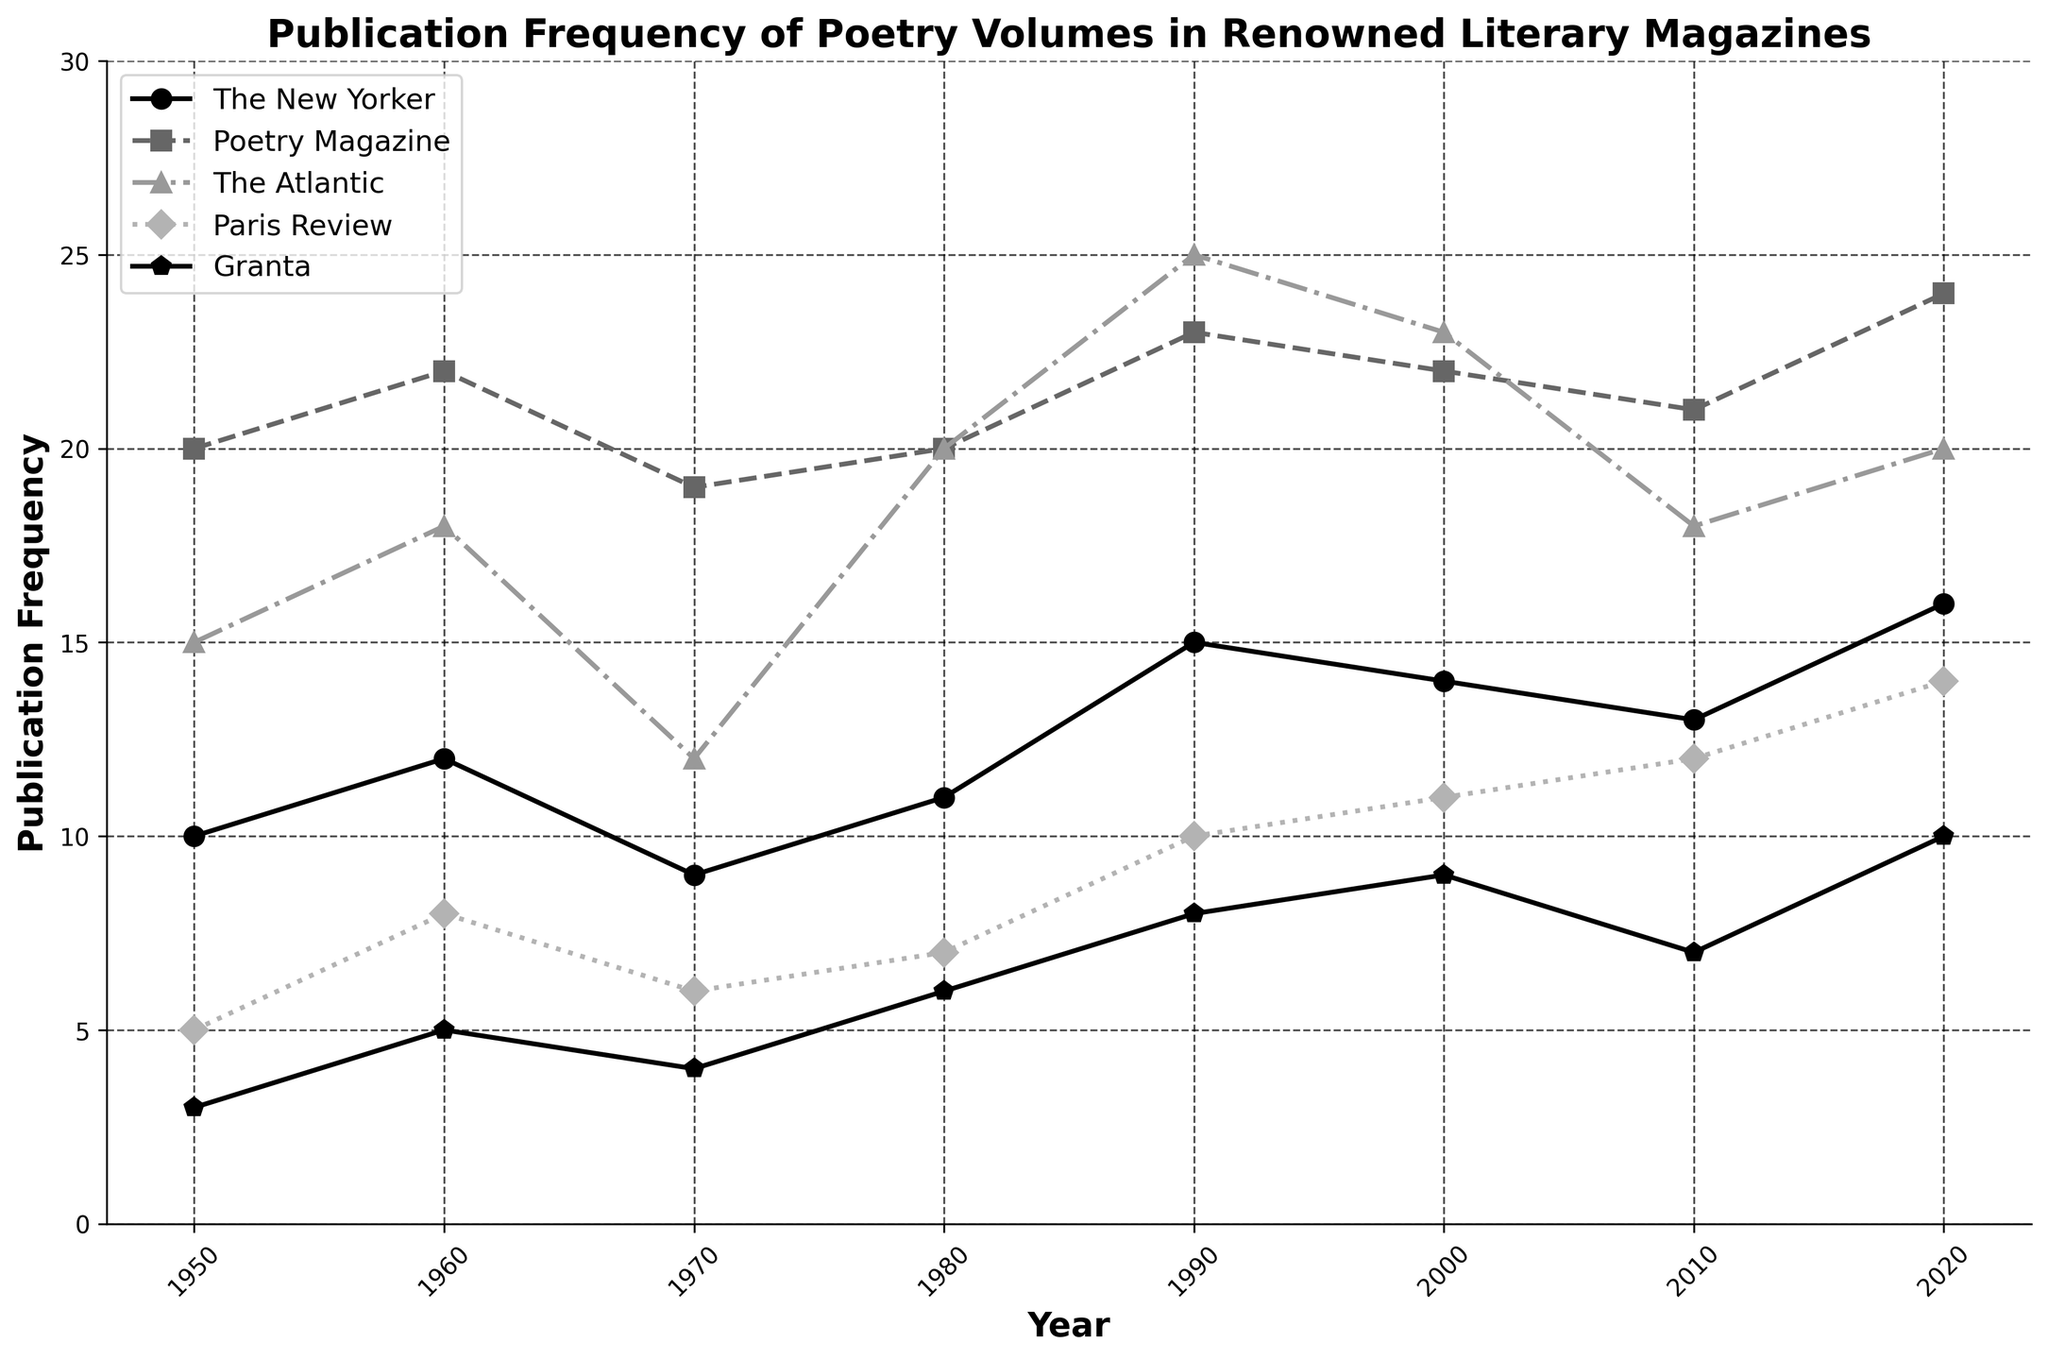How many magazines are represented in the plot? The plot includes lines for different magazines. By counting these lines, you can determine how many distinct magazines are represented.
Answer: 5 Which magazine had the highest publication frequency in 1990? Look at the plot's data points for the year 1990 and identify the magazine with the highest value.
Answer: The Atlantic During which decade does Granta show the most significant increase in publication frequency? Observe the trend line for Granta and identify which decade has the steepest upward slope between two consecutive points.
Answer: 2010s What's the average publication frequency for Paris Review across all decades shown? Sum up all publication frequencies of Paris Review across all the decades and then divide by the number of decades (8) to find the average.
Answer: 9 How did the publication frequency of The New Yorker change from 2000 to 2020? Compare the values for The New Yorker at the years 2000 and 2020 and describe the trend.
Answer: Increased Which year had the lowest publication frequency for Poetry Magazine? Inspect the line plot for Poetry Magazine and identify the year with the lowest value.
Answer: 1970 Which two magazines had the closest publication frequencies in the year 2010? Compare the data points for the year 2010 for each magazine and identify the two magazines whose values are closest to each other.
Answer: The New Yorker and Paris Review By how many units did The Atlantic's publication frequency increase from 1950 to 1990? Subtract the publication frequency in 1950 from the publication frequency in 1990 for The Atlantic.
Answer: 10 Which magazine showed a generally upward trend in publication frequency over the entire period from 1950 to 2020? Examine each magazine's trend over the entire period and identify which one displays a consistent increase without major drops.
Answer: Granta What is the median publication frequency for Poetry Magazine over the decades shown? Arrange the publication frequencies for Poetry Magazine in ascending order and find the middle value (or average of the two middle values). The frequencies are [19, 20, 20, 21, 22, 22, 23, 24], so the median is (21 + 22) / 2.
Answer: 21.5 